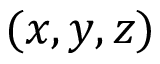Convert formula to latex. <formula><loc_0><loc_0><loc_500><loc_500>( x , y , z )</formula> 